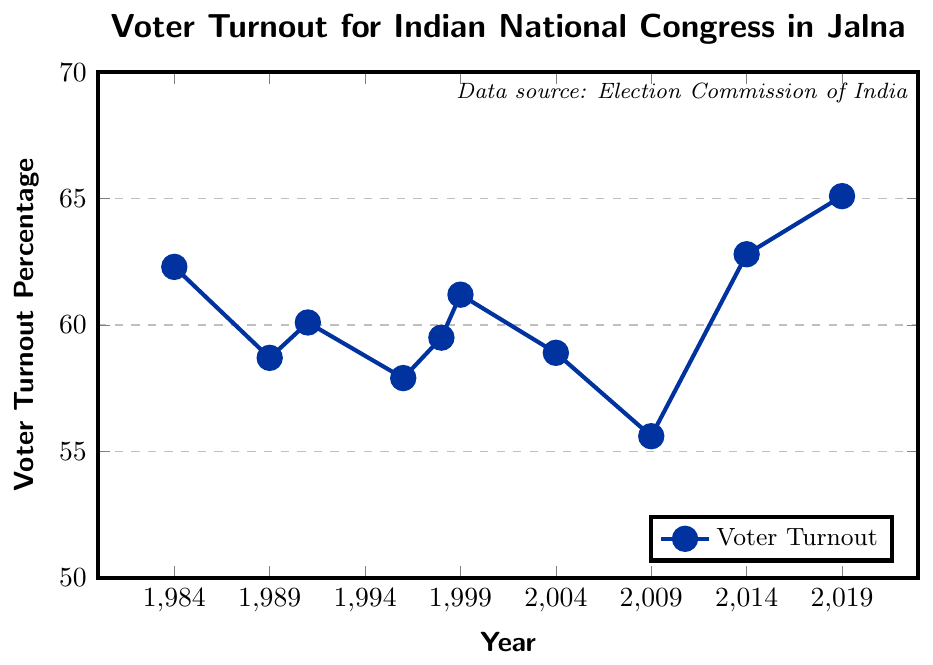What is the voter turnout percentage in the year 2014? First, locate the year 2014 on the x-axis of the chart. Then, follow the corresponding point on the line upwards to find the y-coordinate from the y-axis, which represents the voter turnout percentage.
Answer: 62.8 In which year did the voter turnout percentage drop to the lowest value? To identify the year with the lowest voter turnout percentage, look for the lowest point on the line chart. Then, find the x-coordinate corresponding to this point.
Answer: 2009 What is the difference in voter turnout percentages between 1984 and 2019? Identify and note the voter turnout percentages for the years 1984 (62.3) and 2019 (65.1) from the chart. Then, subtract the 1984 percentage from the 2019 percentage.
Answer: 2.8 What is the average voter turnout percentage over the last 10 elections? First, sum up all the voter turnout percentages from the data. Then, divide the total by the number of years (10). The calculation is (62.3 + 58.7 + 60.1 + 57.9 + 59.5 + 61.2 + 58.9 + 55.6 + 62.8 + 65.1) / 10.
Answer: 60.21 How did the voter turnout change from 1989 to 1991? Identify and compare the voter turnout percentages for the years 1989 (58.7) and 1991 (60.1). Subtract the 1989 percentage from the 1991 percentage to find the change.
Answer: Increase by 1.4 Which period had the most significant increase in voter turnout percentage? Examine the differences in voter turnout percentages between consecutive years and identify the largest increase. The most significant increase is from 2009 (55.6) to 2014 (62.8).
Answer: 2009 to 2014 How many times did the voter turnout percentage decrease in the subsequent election compared to the previous one? Count the number of times the line moves downward from one election year to the next. These decreases occurred between 1984-1989, 1991-1996, 1999-2004, and 2004-2009.
Answer: 4 What was the voter turnout percentage trend from 1996 to 1999? Identify the percentages for 1996 (57.9) and 1999 (61.2) and note the direction of change. The trend indicates an increase from 57.9 to 61.2.
Answer: Increasing Compare the voter turnout percentage in 1991 with the average turnout from 1984 to 1991. First, calculate the average turnout from 1984 to 1991: (62.3 + 58.7 + 60.1) / 3 = 60.37. Then, compare this to the turnout in 1991 (60.1).
Answer: Lower What is the range of voter turnout percentages over these elections? Identify the maximum turnout percentage (65.1 in 2019) and the minimum turnout percentage (55.6 in 2009) and calculate the range by subtracting the minimum from the maximum.
Answer: 9.5 